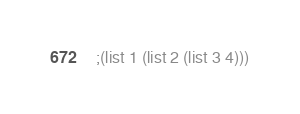<code> <loc_0><loc_0><loc_500><loc_500><_Scheme_>;(list 1 (list 2 (list 3 4)))</code> 